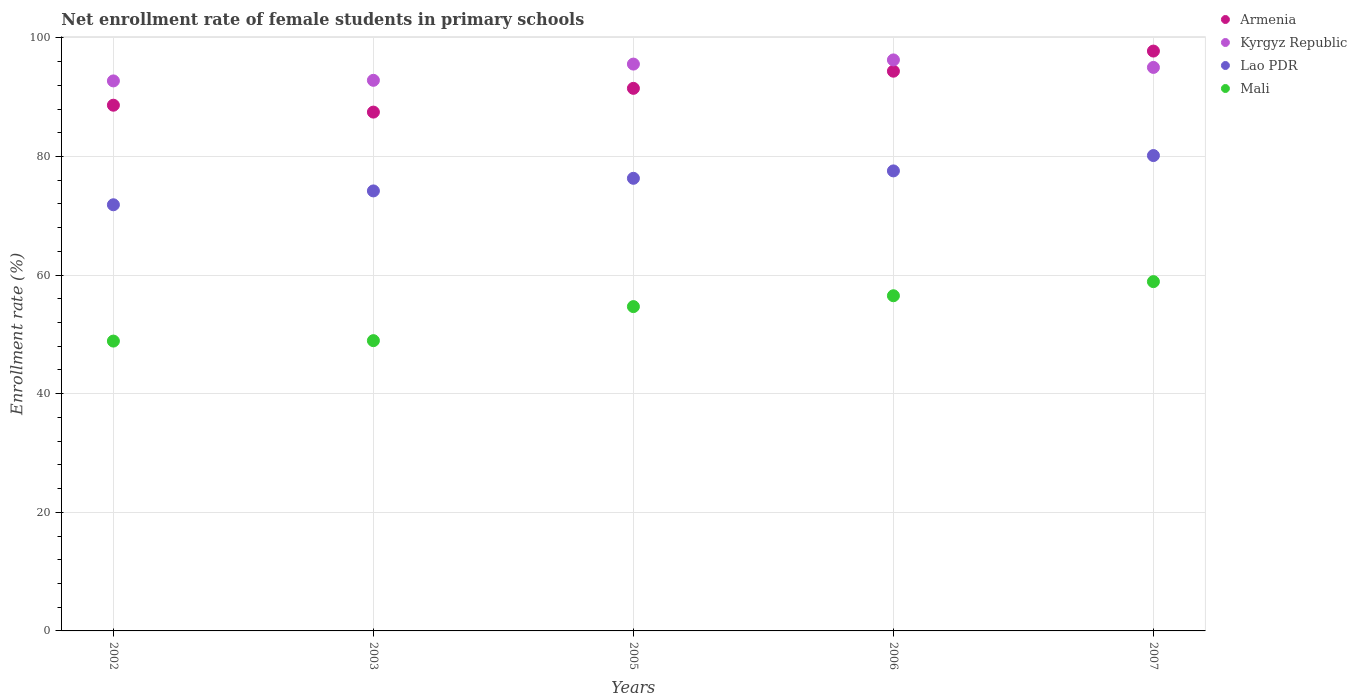How many different coloured dotlines are there?
Provide a short and direct response. 4. What is the net enrollment rate of female students in primary schools in Lao PDR in 2003?
Keep it short and to the point. 74.19. Across all years, what is the maximum net enrollment rate of female students in primary schools in Lao PDR?
Give a very brief answer. 80.16. Across all years, what is the minimum net enrollment rate of female students in primary schools in Armenia?
Keep it short and to the point. 87.48. In which year was the net enrollment rate of female students in primary schools in Mali maximum?
Ensure brevity in your answer.  2007. In which year was the net enrollment rate of female students in primary schools in Mali minimum?
Offer a very short reply. 2002. What is the total net enrollment rate of female students in primary schools in Lao PDR in the graph?
Provide a short and direct response. 380.1. What is the difference between the net enrollment rate of female students in primary schools in Lao PDR in 2002 and that in 2007?
Your response must be concise. -8.3. What is the difference between the net enrollment rate of female students in primary schools in Lao PDR in 2002 and the net enrollment rate of female students in primary schools in Mali in 2005?
Provide a short and direct response. 17.17. What is the average net enrollment rate of female students in primary schools in Mali per year?
Provide a succinct answer. 53.58. In the year 2005, what is the difference between the net enrollment rate of female students in primary schools in Armenia and net enrollment rate of female students in primary schools in Mali?
Make the answer very short. 36.8. What is the ratio of the net enrollment rate of female students in primary schools in Kyrgyz Republic in 2003 to that in 2006?
Provide a succinct answer. 0.96. Is the difference between the net enrollment rate of female students in primary schools in Armenia in 2002 and 2003 greater than the difference between the net enrollment rate of female students in primary schools in Mali in 2002 and 2003?
Provide a succinct answer. Yes. What is the difference between the highest and the second highest net enrollment rate of female students in primary schools in Armenia?
Ensure brevity in your answer.  3.39. What is the difference between the highest and the lowest net enrollment rate of female students in primary schools in Mali?
Ensure brevity in your answer.  10.03. In how many years, is the net enrollment rate of female students in primary schools in Lao PDR greater than the average net enrollment rate of female students in primary schools in Lao PDR taken over all years?
Ensure brevity in your answer.  3. Is the sum of the net enrollment rate of female students in primary schools in Lao PDR in 2002 and 2005 greater than the maximum net enrollment rate of female students in primary schools in Mali across all years?
Ensure brevity in your answer.  Yes. Is it the case that in every year, the sum of the net enrollment rate of female students in primary schools in Armenia and net enrollment rate of female students in primary schools in Mali  is greater than the sum of net enrollment rate of female students in primary schools in Kyrgyz Republic and net enrollment rate of female students in primary schools in Lao PDR?
Provide a succinct answer. Yes. Is the net enrollment rate of female students in primary schools in Lao PDR strictly greater than the net enrollment rate of female students in primary schools in Armenia over the years?
Make the answer very short. No. How many years are there in the graph?
Offer a terse response. 5. Are the values on the major ticks of Y-axis written in scientific E-notation?
Your answer should be very brief. No. Does the graph contain grids?
Offer a very short reply. Yes. What is the title of the graph?
Keep it short and to the point. Net enrollment rate of female students in primary schools. What is the label or title of the Y-axis?
Offer a terse response. Enrollment rate (%). What is the Enrollment rate (%) of Armenia in 2002?
Your answer should be very brief. 88.65. What is the Enrollment rate (%) in Kyrgyz Republic in 2002?
Your answer should be very brief. 92.74. What is the Enrollment rate (%) in Lao PDR in 2002?
Offer a terse response. 71.86. What is the Enrollment rate (%) in Mali in 2002?
Offer a terse response. 48.87. What is the Enrollment rate (%) in Armenia in 2003?
Your response must be concise. 87.48. What is the Enrollment rate (%) in Kyrgyz Republic in 2003?
Your answer should be very brief. 92.84. What is the Enrollment rate (%) of Lao PDR in 2003?
Ensure brevity in your answer.  74.19. What is the Enrollment rate (%) in Mali in 2003?
Your response must be concise. 48.95. What is the Enrollment rate (%) of Armenia in 2005?
Keep it short and to the point. 91.49. What is the Enrollment rate (%) of Kyrgyz Republic in 2005?
Your response must be concise. 95.58. What is the Enrollment rate (%) of Lao PDR in 2005?
Make the answer very short. 76.32. What is the Enrollment rate (%) in Mali in 2005?
Your answer should be very brief. 54.69. What is the Enrollment rate (%) in Armenia in 2006?
Provide a succinct answer. 94.38. What is the Enrollment rate (%) of Kyrgyz Republic in 2006?
Provide a succinct answer. 96.28. What is the Enrollment rate (%) of Lao PDR in 2006?
Your answer should be very brief. 77.57. What is the Enrollment rate (%) of Mali in 2006?
Your answer should be compact. 56.52. What is the Enrollment rate (%) in Armenia in 2007?
Make the answer very short. 97.77. What is the Enrollment rate (%) in Kyrgyz Republic in 2007?
Make the answer very short. 95.02. What is the Enrollment rate (%) of Lao PDR in 2007?
Your answer should be compact. 80.16. What is the Enrollment rate (%) in Mali in 2007?
Keep it short and to the point. 58.9. Across all years, what is the maximum Enrollment rate (%) in Armenia?
Give a very brief answer. 97.77. Across all years, what is the maximum Enrollment rate (%) of Kyrgyz Republic?
Ensure brevity in your answer.  96.28. Across all years, what is the maximum Enrollment rate (%) in Lao PDR?
Make the answer very short. 80.16. Across all years, what is the maximum Enrollment rate (%) of Mali?
Your answer should be compact. 58.9. Across all years, what is the minimum Enrollment rate (%) in Armenia?
Your answer should be very brief. 87.48. Across all years, what is the minimum Enrollment rate (%) in Kyrgyz Republic?
Keep it short and to the point. 92.74. Across all years, what is the minimum Enrollment rate (%) in Lao PDR?
Offer a terse response. 71.86. Across all years, what is the minimum Enrollment rate (%) of Mali?
Your answer should be very brief. 48.87. What is the total Enrollment rate (%) in Armenia in the graph?
Make the answer very short. 459.77. What is the total Enrollment rate (%) of Kyrgyz Republic in the graph?
Ensure brevity in your answer.  472.47. What is the total Enrollment rate (%) in Lao PDR in the graph?
Provide a short and direct response. 380.1. What is the total Enrollment rate (%) in Mali in the graph?
Your response must be concise. 267.92. What is the difference between the Enrollment rate (%) of Armenia in 2002 and that in 2003?
Provide a succinct answer. 1.16. What is the difference between the Enrollment rate (%) of Kyrgyz Republic in 2002 and that in 2003?
Keep it short and to the point. -0.1. What is the difference between the Enrollment rate (%) in Lao PDR in 2002 and that in 2003?
Give a very brief answer. -2.33. What is the difference between the Enrollment rate (%) of Mali in 2002 and that in 2003?
Make the answer very short. -0.07. What is the difference between the Enrollment rate (%) in Armenia in 2002 and that in 2005?
Your answer should be very brief. -2.84. What is the difference between the Enrollment rate (%) of Kyrgyz Republic in 2002 and that in 2005?
Keep it short and to the point. -2.84. What is the difference between the Enrollment rate (%) of Lao PDR in 2002 and that in 2005?
Your answer should be compact. -4.46. What is the difference between the Enrollment rate (%) in Mali in 2002 and that in 2005?
Provide a succinct answer. -5.81. What is the difference between the Enrollment rate (%) in Armenia in 2002 and that in 2006?
Provide a succinct answer. -5.73. What is the difference between the Enrollment rate (%) of Kyrgyz Republic in 2002 and that in 2006?
Provide a succinct answer. -3.54. What is the difference between the Enrollment rate (%) of Lao PDR in 2002 and that in 2006?
Provide a short and direct response. -5.71. What is the difference between the Enrollment rate (%) in Mali in 2002 and that in 2006?
Your response must be concise. -7.64. What is the difference between the Enrollment rate (%) in Armenia in 2002 and that in 2007?
Ensure brevity in your answer.  -9.13. What is the difference between the Enrollment rate (%) of Kyrgyz Republic in 2002 and that in 2007?
Keep it short and to the point. -2.27. What is the difference between the Enrollment rate (%) of Lao PDR in 2002 and that in 2007?
Your answer should be very brief. -8.3. What is the difference between the Enrollment rate (%) in Mali in 2002 and that in 2007?
Provide a short and direct response. -10.03. What is the difference between the Enrollment rate (%) in Armenia in 2003 and that in 2005?
Your answer should be compact. -4.01. What is the difference between the Enrollment rate (%) of Kyrgyz Republic in 2003 and that in 2005?
Provide a short and direct response. -2.74. What is the difference between the Enrollment rate (%) of Lao PDR in 2003 and that in 2005?
Your answer should be compact. -2.13. What is the difference between the Enrollment rate (%) of Mali in 2003 and that in 2005?
Give a very brief answer. -5.74. What is the difference between the Enrollment rate (%) of Armenia in 2003 and that in 2006?
Your answer should be very brief. -6.9. What is the difference between the Enrollment rate (%) of Kyrgyz Republic in 2003 and that in 2006?
Your answer should be very brief. -3.44. What is the difference between the Enrollment rate (%) in Lao PDR in 2003 and that in 2006?
Keep it short and to the point. -3.38. What is the difference between the Enrollment rate (%) in Mali in 2003 and that in 2006?
Keep it short and to the point. -7.57. What is the difference between the Enrollment rate (%) of Armenia in 2003 and that in 2007?
Your answer should be compact. -10.29. What is the difference between the Enrollment rate (%) of Kyrgyz Republic in 2003 and that in 2007?
Offer a very short reply. -2.17. What is the difference between the Enrollment rate (%) of Lao PDR in 2003 and that in 2007?
Give a very brief answer. -5.96. What is the difference between the Enrollment rate (%) in Mali in 2003 and that in 2007?
Provide a succinct answer. -9.95. What is the difference between the Enrollment rate (%) of Armenia in 2005 and that in 2006?
Give a very brief answer. -2.89. What is the difference between the Enrollment rate (%) of Kyrgyz Republic in 2005 and that in 2006?
Offer a terse response. -0.7. What is the difference between the Enrollment rate (%) in Lao PDR in 2005 and that in 2006?
Offer a very short reply. -1.25. What is the difference between the Enrollment rate (%) in Mali in 2005 and that in 2006?
Offer a very short reply. -1.83. What is the difference between the Enrollment rate (%) of Armenia in 2005 and that in 2007?
Make the answer very short. -6.28. What is the difference between the Enrollment rate (%) in Kyrgyz Republic in 2005 and that in 2007?
Provide a short and direct response. 0.56. What is the difference between the Enrollment rate (%) of Lao PDR in 2005 and that in 2007?
Offer a terse response. -3.84. What is the difference between the Enrollment rate (%) of Mali in 2005 and that in 2007?
Your response must be concise. -4.21. What is the difference between the Enrollment rate (%) in Armenia in 2006 and that in 2007?
Ensure brevity in your answer.  -3.39. What is the difference between the Enrollment rate (%) in Kyrgyz Republic in 2006 and that in 2007?
Provide a short and direct response. 1.26. What is the difference between the Enrollment rate (%) of Lao PDR in 2006 and that in 2007?
Offer a very short reply. -2.59. What is the difference between the Enrollment rate (%) of Mali in 2006 and that in 2007?
Provide a short and direct response. -2.38. What is the difference between the Enrollment rate (%) of Armenia in 2002 and the Enrollment rate (%) of Kyrgyz Republic in 2003?
Make the answer very short. -4.2. What is the difference between the Enrollment rate (%) of Armenia in 2002 and the Enrollment rate (%) of Lao PDR in 2003?
Ensure brevity in your answer.  14.45. What is the difference between the Enrollment rate (%) of Armenia in 2002 and the Enrollment rate (%) of Mali in 2003?
Provide a short and direct response. 39.7. What is the difference between the Enrollment rate (%) in Kyrgyz Republic in 2002 and the Enrollment rate (%) in Lao PDR in 2003?
Your response must be concise. 18.55. What is the difference between the Enrollment rate (%) in Kyrgyz Republic in 2002 and the Enrollment rate (%) in Mali in 2003?
Make the answer very short. 43.8. What is the difference between the Enrollment rate (%) of Lao PDR in 2002 and the Enrollment rate (%) of Mali in 2003?
Your answer should be very brief. 22.91. What is the difference between the Enrollment rate (%) in Armenia in 2002 and the Enrollment rate (%) in Kyrgyz Republic in 2005?
Provide a succinct answer. -6.93. What is the difference between the Enrollment rate (%) in Armenia in 2002 and the Enrollment rate (%) in Lao PDR in 2005?
Give a very brief answer. 12.33. What is the difference between the Enrollment rate (%) of Armenia in 2002 and the Enrollment rate (%) of Mali in 2005?
Your response must be concise. 33.96. What is the difference between the Enrollment rate (%) of Kyrgyz Republic in 2002 and the Enrollment rate (%) of Lao PDR in 2005?
Your answer should be compact. 16.42. What is the difference between the Enrollment rate (%) of Kyrgyz Republic in 2002 and the Enrollment rate (%) of Mali in 2005?
Provide a succinct answer. 38.06. What is the difference between the Enrollment rate (%) of Lao PDR in 2002 and the Enrollment rate (%) of Mali in 2005?
Provide a short and direct response. 17.17. What is the difference between the Enrollment rate (%) in Armenia in 2002 and the Enrollment rate (%) in Kyrgyz Republic in 2006?
Your answer should be compact. -7.64. What is the difference between the Enrollment rate (%) in Armenia in 2002 and the Enrollment rate (%) in Lao PDR in 2006?
Your answer should be very brief. 11.08. What is the difference between the Enrollment rate (%) of Armenia in 2002 and the Enrollment rate (%) of Mali in 2006?
Offer a terse response. 32.13. What is the difference between the Enrollment rate (%) of Kyrgyz Republic in 2002 and the Enrollment rate (%) of Lao PDR in 2006?
Your response must be concise. 15.17. What is the difference between the Enrollment rate (%) of Kyrgyz Republic in 2002 and the Enrollment rate (%) of Mali in 2006?
Provide a succinct answer. 36.23. What is the difference between the Enrollment rate (%) in Lao PDR in 2002 and the Enrollment rate (%) in Mali in 2006?
Your answer should be compact. 15.34. What is the difference between the Enrollment rate (%) in Armenia in 2002 and the Enrollment rate (%) in Kyrgyz Republic in 2007?
Make the answer very short. -6.37. What is the difference between the Enrollment rate (%) of Armenia in 2002 and the Enrollment rate (%) of Lao PDR in 2007?
Your response must be concise. 8.49. What is the difference between the Enrollment rate (%) in Armenia in 2002 and the Enrollment rate (%) in Mali in 2007?
Offer a very short reply. 29.75. What is the difference between the Enrollment rate (%) in Kyrgyz Republic in 2002 and the Enrollment rate (%) in Lao PDR in 2007?
Offer a very short reply. 12.59. What is the difference between the Enrollment rate (%) of Kyrgyz Republic in 2002 and the Enrollment rate (%) of Mali in 2007?
Provide a succinct answer. 33.85. What is the difference between the Enrollment rate (%) in Lao PDR in 2002 and the Enrollment rate (%) in Mali in 2007?
Offer a terse response. 12.96. What is the difference between the Enrollment rate (%) of Armenia in 2003 and the Enrollment rate (%) of Kyrgyz Republic in 2005?
Your answer should be compact. -8.1. What is the difference between the Enrollment rate (%) in Armenia in 2003 and the Enrollment rate (%) in Lao PDR in 2005?
Make the answer very short. 11.16. What is the difference between the Enrollment rate (%) in Armenia in 2003 and the Enrollment rate (%) in Mali in 2005?
Your response must be concise. 32.8. What is the difference between the Enrollment rate (%) in Kyrgyz Republic in 2003 and the Enrollment rate (%) in Lao PDR in 2005?
Offer a very short reply. 16.52. What is the difference between the Enrollment rate (%) of Kyrgyz Republic in 2003 and the Enrollment rate (%) of Mali in 2005?
Ensure brevity in your answer.  38.16. What is the difference between the Enrollment rate (%) of Lao PDR in 2003 and the Enrollment rate (%) of Mali in 2005?
Offer a terse response. 19.51. What is the difference between the Enrollment rate (%) in Armenia in 2003 and the Enrollment rate (%) in Kyrgyz Republic in 2006?
Keep it short and to the point. -8.8. What is the difference between the Enrollment rate (%) of Armenia in 2003 and the Enrollment rate (%) of Lao PDR in 2006?
Give a very brief answer. 9.92. What is the difference between the Enrollment rate (%) of Armenia in 2003 and the Enrollment rate (%) of Mali in 2006?
Give a very brief answer. 30.97. What is the difference between the Enrollment rate (%) of Kyrgyz Republic in 2003 and the Enrollment rate (%) of Lao PDR in 2006?
Your response must be concise. 15.28. What is the difference between the Enrollment rate (%) of Kyrgyz Republic in 2003 and the Enrollment rate (%) of Mali in 2006?
Keep it short and to the point. 36.33. What is the difference between the Enrollment rate (%) of Lao PDR in 2003 and the Enrollment rate (%) of Mali in 2006?
Provide a short and direct response. 17.68. What is the difference between the Enrollment rate (%) of Armenia in 2003 and the Enrollment rate (%) of Kyrgyz Republic in 2007?
Keep it short and to the point. -7.53. What is the difference between the Enrollment rate (%) of Armenia in 2003 and the Enrollment rate (%) of Lao PDR in 2007?
Keep it short and to the point. 7.33. What is the difference between the Enrollment rate (%) in Armenia in 2003 and the Enrollment rate (%) in Mali in 2007?
Keep it short and to the point. 28.59. What is the difference between the Enrollment rate (%) of Kyrgyz Republic in 2003 and the Enrollment rate (%) of Lao PDR in 2007?
Your response must be concise. 12.69. What is the difference between the Enrollment rate (%) of Kyrgyz Republic in 2003 and the Enrollment rate (%) of Mali in 2007?
Give a very brief answer. 33.95. What is the difference between the Enrollment rate (%) of Lao PDR in 2003 and the Enrollment rate (%) of Mali in 2007?
Ensure brevity in your answer.  15.3. What is the difference between the Enrollment rate (%) of Armenia in 2005 and the Enrollment rate (%) of Kyrgyz Republic in 2006?
Provide a succinct answer. -4.79. What is the difference between the Enrollment rate (%) of Armenia in 2005 and the Enrollment rate (%) of Lao PDR in 2006?
Your answer should be compact. 13.92. What is the difference between the Enrollment rate (%) in Armenia in 2005 and the Enrollment rate (%) in Mali in 2006?
Give a very brief answer. 34.97. What is the difference between the Enrollment rate (%) of Kyrgyz Republic in 2005 and the Enrollment rate (%) of Lao PDR in 2006?
Offer a terse response. 18.01. What is the difference between the Enrollment rate (%) in Kyrgyz Republic in 2005 and the Enrollment rate (%) in Mali in 2006?
Ensure brevity in your answer.  39.06. What is the difference between the Enrollment rate (%) of Lao PDR in 2005 and the Enrollment rate (%) of Mali in 2006?
Provide a succinct answer. 19.8. What is the difference between the Enrollment rate (%) of Armenia in 2005 and the Enrollment rate (%) of Kyrgyz Republic in 2007?
Provide a succinct answer. -3.53. What is the difference between the Enrollment rate (%) in Armenia in 2005 and the Enrollment rate (%) in Lao PDR in 2007?
Give a very brief answer. 11.33. What is the difference between the Enrollment rate (%) of Armenia in 2005 and the Enrollment rate (%) of Mali in 2007?
Make the answer very short. 32.59. What is the difference between the Enrollment rate (%) of Kyrgyz Republic in 2005 and the Enrollment rate (%) of Lao PDR in 2007?
Provide a succinct answer. 15.42. What is the difference between the Enrollment rate (%) in Kyrgyz Republic in 2005 and the Enrollment rate (%) in Mali in 2007?
Your response must be concise. 36.68. What is the difference between the Enrollment rate (%) in Lao PDR in 2005 and the Enrollment rate (%) in Mali in 2007?
Offer a very short reply. 17.42. What is the difference between the Enrollment rate (%) of Armenia in 2006 and the Enrollment rate (%) of Kyrgyz Republic in 2007?
Ensure brevity in your answer.  -0.64. What is the difference between the Enrollment rate (%) of Armenia in 2006 and the Enrollment rate (%) of Lao PDR in 2007?
Make the answer very short. 14.22. What is the difference between the Enrollment rate (%) in Armenia in 2006 and the Enrollment rate (%) in Mali in 2007?
Give a very brief answer. 35.48. What is the difference between the Enrollment rate (%) of Kyrgyz Republic in 2006 and the Enrollment rate (%) of Lao PDR in 2007?
Make the answer very short. 16.13. What is the difference between the Enrollment rate (%) in Kyrgyz Republic in 2006 and the Enrollment rate (%) in Mali in 2007?
Provide a short and direct response. 37.38. What is the difference between the Enrollment rate (%) of Lao PDR in 2006 and the Enrollment rate (%) of Mali in 2007?
Give a very brief answer. 18.67. What is the average Enrollment rate (%) of Armenia per year?
Offer a very short reply. 91.95. What is the average Enrollment rate (%) of Kyrgyz Republic per year?
Your answer should be very brief. 94.49. What is the average Enrollment rate (%) of Lao PDR per year?
Your answer should be very brief. 76.02. What is the average Enrollment rate (%) of Mali per year?
Ensure brevity in your answer.  53.58. In the year 2002, what is the difference between the Enrollment rate (%) of Armenia and Enrollment rate (%) of Kyrgyz Republic?
Provide a short and direct response. -4.1. In the year 2002, what is the difference between the Enrollment rate (%) in Armenia and Enrollment rate (%) in Lao PDR?
Ensure brevity in your answer.  16.79. In the year 2002, what is the difference between the Enrollment rate (%) in Armenia and Enrollment rate (%) in Mali?
Ensure brevity in your answer.  39.77. In the year 2002, what is the difference between the Enrollment rate (%) in Kyrgyz Republic and Enrollment rate (%) in Lao PDR?
Provide a succinct answer. 20.88. In the year 2002, what is the difference between the Enrollment rate (%) in Kyrgyz Republic and Enrollment rate (%) in Mali?
Your answer should be compact. 43.87. In the year 2002, what is the difference between the Enrollment rate (%) in Lao PDR and Enrollment rate (%) in Mali?
Provide a succinct answer. 22.99. In the year 2003, what is the difference between the Enrollment rate (%) in Armenia and Enrollment rate (%) in Kyrgyz Republic?
Make the answer very short. -5.36. In the year 2003, what is the difference between the Enrollment rate (%) of Armenia and Enrollment rate (%) of Lao PDR?
Your response must be concise. 13.29. In the year 2003, what is the difference between the Enrollment rate (%) of Armenia and Enrollment rate (%) of Mali?
Your answer should be very brief. 38.54. In the year 2003, what is the difference between the Enrollment rate (%) of Kyrgyz Republic and Enrollment rate (%) of Lao PDR?
Ensure brevity in your answer.  18.65. In the year 2003, what is the difference between the Enrollment rate (%) of Kyrgyz Republic and Enrollment rate (%) of Mali?
Give a very brief answer. 43.9. In the year 2003, what is the difference between the Enrollment rate (%) in Lao PDR and Enrollment rate (%) in Mali?
Keep it short and to the point. 25.25. In the year 2005, what is the difference between the Enrollment rate (%) in Armenia and Enrollment rate (%) in Kyrgyz Republic?
Give a very brief answer. -4.09. In the year 2005, what is the difference between the Enrollment rate (%) of Armenia and Enrollment rate (%) of Lao PDR?
Your response must be concise. 15.17. In the year 2005, what is the difference between the Enrollment rate (%) in Armenia and Enrollment rate (%) in Mali?
Offer a terse response. 36.8. In the year 2005, what is the difference between the Enrollment rate (%) of Kyrgyz Republic and Enrollment rate (%) of Lao PDR?
Your response must be concise. 19.26. In the year 2005, what is the difference between the Enrollment rate (%) of Kyrgyz Republic and Enrollment rate (%) of Mali?
Your answer should be very brief. 40.89. In the year 2005, what is the difference between the Enrollment rate (%) in Lao PDR and Enrollment rate (%) in Mali?
Keep it short and to the point. 21.63. In the year 2006, what is the difference between the Enrollment rate (%) of Armenia and Enrollment rate (%) of Kyrgyz Republic?
Provide a short and direct response. -1.9. In the year 2006, what is the difference between the Enrollment rate (%) in Armenia and Enrollment rate (%) in Lao PDR?
Provide a succinct answer. 16.81. In the year 2006, what is the difference between the Enrollment rate (%) in Armenia and Enrollment rate (%) in Mali?
Give a very brief answer. 37.86. In the year 2006, what is the difference between the Enrollment rate (%) in Kyrgyz Republic and Enrollment rate (%) in Lao PDR?
Provide a short and direct response. 18.71. In the year 2006, what is the difference between the Enrollment rate (%) in Kyrgyz Republic and Enrollment rate (%) in Mali?
Your answer should be compact. 39.77. In the year 2006, what is the difference between the Enrollment rate (%) of Lao PDR and Enrollment rate (%) of Mali?
Keep it short and to the point. 21.05. In the year 2007, what is the difference between the Enrollment rate (%) in Armenia and Enrollment rate (%) in Kyrgyz Republic?
Offer a terse response. 2.76. In the year 2007, what is the difference between the Enrollment rate (%) of Armenia and Enrollment rate (%) of Lao PDR?
Keep it short and to the point. 17.62. In the year 2007, what is the difference between the Enrollment rate (%) in Armenia and Enrollment rate (%) in Mali?
Offer a terse response. 38.88. In the year 2007, what is the difference between the Enrollment rate (%) of Kyrgyz Republic and Enrollment rate (%) of Lao PDR?
Your answer should be very brief. 14.86. In the year 2007, what is the difference between the Enrollment rate (%) in Kyrgyz Republic and Enrollment rate (%) in Mali?
Give a very brief answer. 36.12. In the year 2007, what is the difference between the Enrollment rate (%) of Lao PDR and Enrollment rate (%) of Mali?
Make the answer very short. 21.26. What is the ratio of the Enrollment rate (%) in Armenia in 2002 to that in 2003?
Your response must be concise. 1.01. What is the ratio of the Enrollment rate (%) of Kyrgyz Republic in 2002 to that in 2003?
Offer a very short reply. 1. What is the ratio of the Enrollment rate (%) in Lao PDR in 2002 to that in 2003?
Give a very brief answer. 0.97. What is the ratio of the Enrollment rate (%) of Mali in 2002 to that in 2003?
Offer a terse response. 1. What is the ratio of the Enrollment rate (%) of Armenia in 2002 to that in 2005?
Offer a very short reply. 0.97. What is the ratio of the Enrollment rate (%) in Kyrgyz Republic in 2002 to that in 2005?
Your response must be concise. 0.97. What is the ratio of the Enrollment rate (%) of Lao PDR in 2002 to that in 2005?
Make the answer very short. 0.94. What is the ratio of the Enrollment rate (%) of Mali in 2002 to that in 2005?
Provide a short and direct response. 0.89. What is the ratio of the Enrollment rate (%) in Armenia in 2002 to that in 2006?
Your answer should be compact. 0.94. What is the ratio of the Enrollment rate (%) of Kyrgyz Republic in 2002 to that in 2006?
Your response must be concise. 0.96. What is the ratio of the Enrollment rate (%) in Lao PDR in 2002 to that in 2006?
Make the answer very short. 0.93. What is the ratio of the Enrollment rate (%) of Mali in 2002 to that in 2006?
Offer a very short reply. 0.86. What is the ratio of the Enrollment rate (%) in Armenia in 2002 to that in 2007?
Provide a short and direct response. 0.91. What is the ratio of the Enrollment rate (%) of Kyrgyz Republic in 2002 to that in 2007?
Provide a succinct answer. 0.98. What is the ratio of the Enrollment rate (%) of Lao PDR in 2002 to that in 2007?
Your answer should be compact. 0.9. What is the ratio of the Enrollment rate (%) of Mali in 2002 to that in 2007?
Your answer should be compact. 0.83. What is the ratio of the Enrollment rate (%) in Armenia in 2003 to that in 2005?
Offer a terse response. 0.96. What is the ratio of the Enrollment rate (%) in Kyrgyz Republic in 2003 to that in 2005?
Provide a succinct answer. 0.97. What is the ratio of the Enrollment rate (%) in Lao PDR in 2003 to that in 2005?
Your answer should be very brief. 0.97. What is the ratio of the Enrollment rate (%) in Mali in 2003 to that in 2005?
Ensure brevity in your answer.  0.9. What is the ratio of the Enrollment rate (%) of Armenia in 2003 to that in 2006?
Keep it short and to the point. 0.93. What is the ratio of the Enrollment rate (%) in Lao PDR in 2003 to that in 2006?
Make the answer very short. 0.96. What is the ratio of the Enrollment rate (%) in Mali in 2003 to that in 2006?
Ensure brevity in your answer.  0.87. What is the ratio of the Enrollment rate (%) in Armenia in 2003 to that in 2007?
Give a very brief answer. 0.89. What is the ratio of the Enrollment rate (%) in Kyrgyz Republic in 2003 to that in 2007?
Keep it short and to the point. 0.98. What is the ratio of the Enrollment rate (%) of Lao PDR in 2003 to that in 2007?
Provide a short and direct response. 0.93. What is the ratio of the Enrollment rate (%) of Mali in 2003 to that in 2007?
Ensure brevity in your answer.  0.83. What is the ratio of the Enrollment rate (%) in Armenia in 2005 to that in 2006?
Provide a succinct answer. 0.97. What is the ratio of the Enrollment rate (%) of Kyrgyz Republic in 2005 to that in 2006?
Ensure brevity in your answer.  0.99. What is the ratio of the Enrollment rate (%) in Lao PDR in 2005 to that in 2006?
Keep it short and to the point. 0.98. What is the ratio of the Enrollment rate (%) of Mali in 2005 to that in 2006?
Make the answer very short. 0.97. What is the ratio of the Enrollment rate (%) of Armenia in 2005 to that in 2007?
Your answer should be very brief. 0.94. What is the ratio of the Enrollment rate (%) of Kyrgyz Republic in 2005 to that in 2007?
Provide a short and direct response. 1.01. What is the ratio of the Enrollment rate (%) in Lao PDR in 2005 to that in 2007?
Your response must be concise. 0.95. What is the ratio of the Enrollment rate (%) of Mali in 2005 to that in 2007?
Your response must be concise. 0.93. What is the ratio of the Enrollment rate (%) in Armenia in 2006 to that in 2007?
Give a very brief answer. 0.97. What is the ratio of the Enrollment rate (%) of Kyrgyz Republic in 2006 to that in 2007?
Give a very brief answer. 1.01. What is the ratio of the Enrollment rate (%) of Mali in 2006 to that in 2007?
Offer a very short reply. 0.96. What is the difference between the highest and the second highest Enrollment rate (%) in Armenia?
Offer a terse response. 3.39. What is the difference between the highest and the second highest Enrollment rate (%) of Kyrgyz Republic?
Your response must be concise. 0.7. What is the difference between the highest and the second highest Enrollment rate (%) of Lao PDR?
Make the answer very short. 2.59. What is the difference between the highest and the second highest Enrollment rate (%) in Mali?
Provide a succinct answer. 2.38. What is the difference between the highest and the lowest Enrollment rate (%) of Armenia?
Make the answer very short. 10.29. What is the difference between the highest and the lowest Enrollment rate (%) in Kyrgyz Republic?
Make the answer very short. 3.54. What is the difference between the highest and the lowest Enrollment rate (%) in Lao PDR?
Offer a very short reply. 8.3. What is the difference between the highest and the lowest Enrollment rate (%) of Mali?
Your response must be concise. 10.03. 